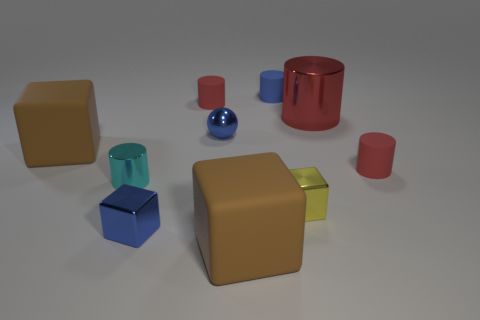Are there any red shiny cylinders of the same size as the blue sphere?
Ensure brevity in your answer.  No. There is a cyan cylinder that is the same size as the blue metallic sphere; what is its material?
Give a very brief answer. Metal. Does the blue rubber cylinder have the same size as the brown cube behind the small yellow cube?
Give a very brief answer. No. What material is the tiny red thing that is in front of the red metal cylinder?
Ensure brevity in your answer.  Rubber. Is the number of big brown rubber objects that are on the left side of the tiny sphere the same as the number of red objects?
Your response must be concise. No. Is the cyan shiny cylinder the same size as the blue ball?
Offer a very short reply. Yes. Is there a large red metal cylinder in front of the thing left of the tiny shiny cylinder that is behind the tiny yellow metal cube?
Make the answer very short. No. There is a tiny cyan object that is the same shape as the big red shiny object; what material is it?
Ensure brevity in your answer.  Metal. How many matte cylinders are left of the red metallic object that is to the right of the cyan object?
Make the answer very short. 2. There is a brown object in front of the brown rubber object that is behind the red matte object that is right of the large shiny cylinder; what size is it?
Your answer should be compact. Large. 